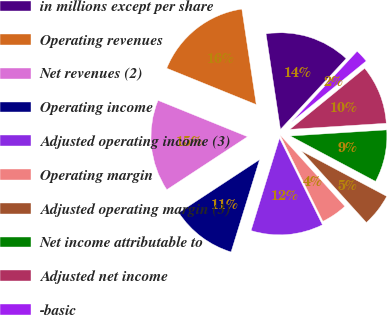<chart> <loc_0><loc_0><loc_500><loc_500><pie_chart><fcel>in millions except per share<fcel>Operating revenues<fcel>Net revenues (2)<fcel>Operating income<fcel>Adjusted operating income (3)<fcel>Operating margin<fcel>Adjusted operating margin (3)<fcel>Net income attributable to<fcel>Adjusted net income<fcel>-basic<nl><fcel>14.29%<fcel>16.48%<fcel>15.38%<fcel>10.99%<fcel>12.09%<fcel>4.4%<fcel>5.49%<fcel>8.79%<fcel>9.89%<fcel>2.2%<nl></chart> 